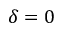<formula> <loc_0><loc_0><loc_500><loc_500>\delta = 0</formula> 